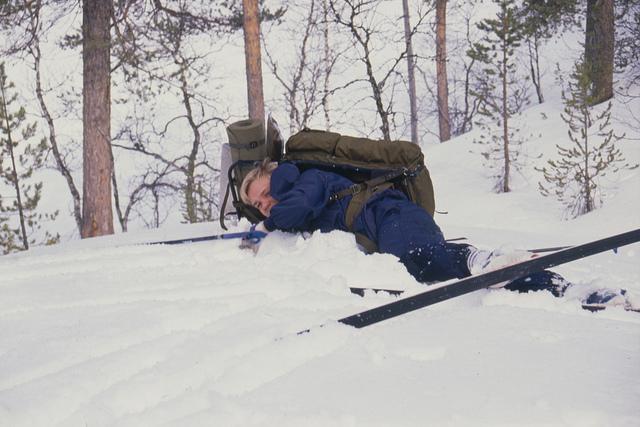Is this person standing up?
Quick response, please. No. Is he hurt?
Keep it brief. Yes. Is it summer in this picture?
Give a very brief answer. No. 